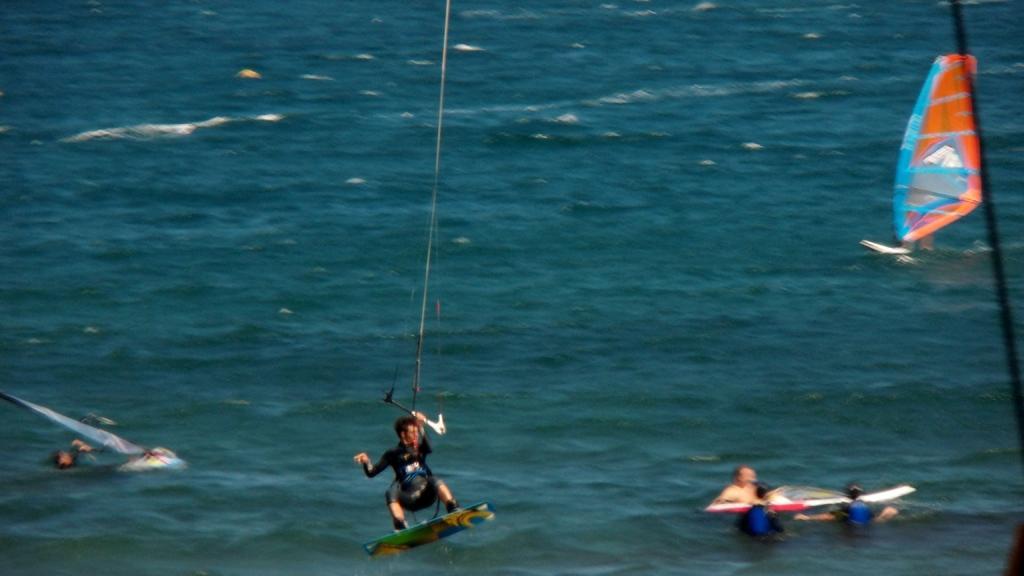Describe this image in one or two sentences. In this image we can see there is a person with a ski board on the water and holding a stick. And there are other people on the water holding a boat. 